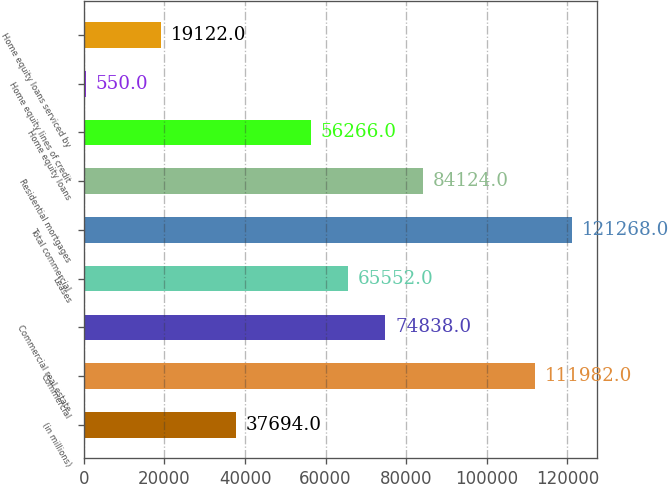Convert chart to OTSL. <chart><loc_0><loc_0><loc_500><loc_500><bar_chart><fcel>(in millions)<fcel>Commercial<fcel>Commercial real estate<fcel>Leases<fcel>Total commercial<fcel>Residential mortgages<fcel>Home equity loans<fcel>Home equity lines of credit<fcel>Home equity loans serviced by<nl><fcel>37694<fcel>111982<fcel>74838<fcel>65552<fcel>121268<fcel>84124<fcel>56266<fcel>550<fcel>19122<nl></chart> 